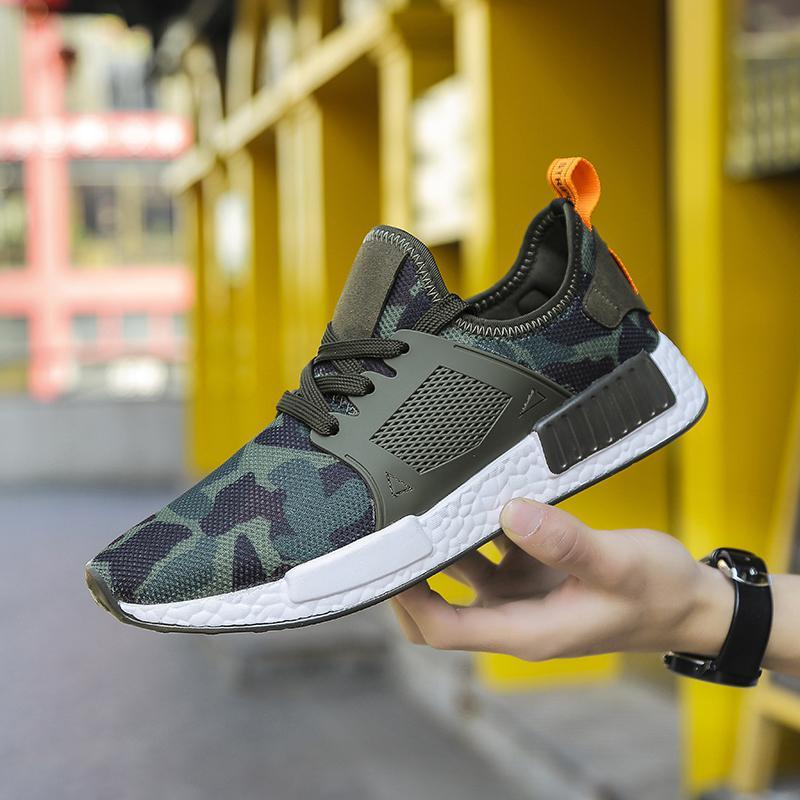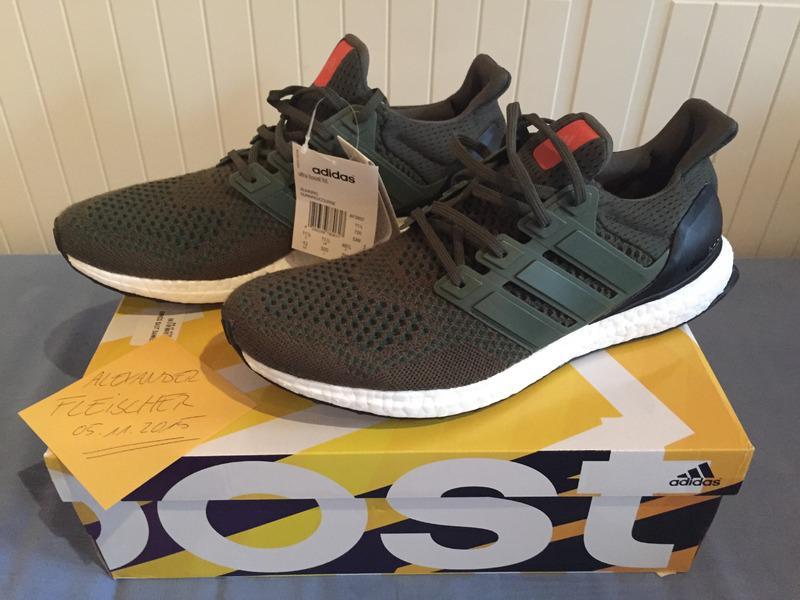The first image is the image on the left, the second image is the image on the right. For the images shown, is this caption "There is a black pair of sneakers sitting on a shoe box in the image on the right." true? Answer yes or no. Yes. The first image is the image on the left, the second image is the image on the right. For the images displayed, is the sentence "An image shows a pair of black sneakers posed on a shoe box." factually correct? Answer yes or no. Yes. 